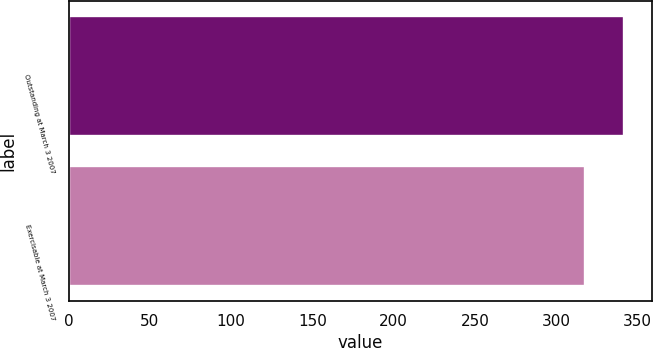Convert chart. <chart><loc_0><loc_0><loc_500><loc_500><bar_chart><fcel>Outstanding at March 3 2007<fcel>Exercisable at March 3 2007<nl><fcel>342<fcel>318<nl></chart> 